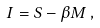<formula> <loc_0><loc_0><loc_500><loc_500>I = S - \beta M \, ,</formula> 